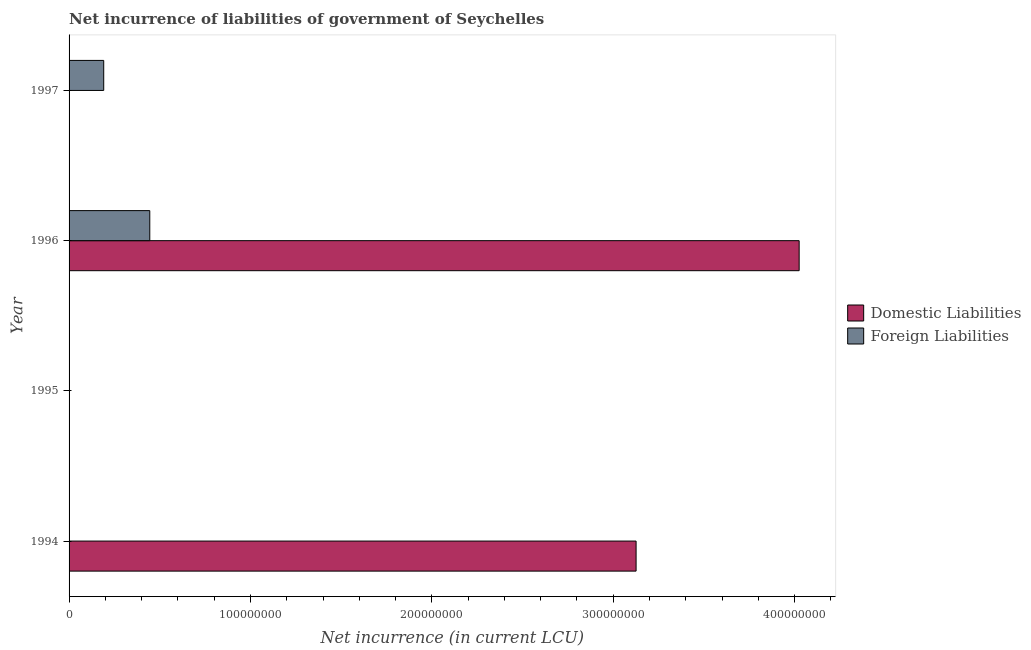How many different coloured bars are there?
Your answer should be very brief. 2. How many bars are there on the 2nd tick from the top?
Provide a short and direct response. 2. What is the label of the 3rd group of bars from the top?
Provide a succinct answer. 1995. In how many cases, is the number of bars for a given year not equal to the number of legend labels?
Give a very brief answer. 3. Across all years, what is the maximum net incurrence of foreign liabilities?
Ensure brevity in your answer.  4.45e+07. Across all years, what is the minimum net incurrence of foreign liabilities?
Provide a succinct answer. 0. What is the total net incurrence of foreign liabilities in the graph?
Give a very brief answer. 6.36e+07. What is the difference between the net incurrence of foreign liabilities in 1996 and that in 1997?
Give a very brief answer. 2.54e+07. What is the difference between the net incurrence of domestic liabilities in 1996 and the net incurrence of foreign liabilities in 1997?
Your response must be concise. 3.83e+08. What is the average net incurrence of foreign liabilities per year?
Offer a terse response. 1.59e+07. In the year 1996, what is the difference between the net incurrence of domestic liabilities and net incurrence of foreign liabilities?
Keep it short and to the point. 3.58e+08. In how many years, is the net incurrence of domestic liabilities greater than 60000000 LCU?
Offer a terse response. 2. What is the ratio of the net incurrence of foreign liabilities in 1996 to that in 1997?
Keep it short and to the point. 2.33. What is the difference between the highest and the lowest net incurrence of domestic liabilities?
Offer a terse response. 4.02e+08. How many bars are there?
Offer a terse response. 4. Are all the bars in the graph horizontal?
Give a very brief answer. Yes. Does the graph contain any zero values?
Your answer should be compact. Yes. What is the title of the graph?
Your response must be concise. Net incurrence of liabilities of government of Seychelles. Does "Rural Population" appear as one of the legend labels in the graph?
Your answer should be compact. No. What is the label or title of the X-axis?
Offer a very short reply. Net incurrence (in current LCU). What is the label or title of the Y-axis?
Provide a short and direct response. Year. What is the Net incurrence (in current LCU) in Domestic Liabilities in 1994?
Your response must be concise. 3.13e+08. What is the Net incurrence (in current LCU) in Domestic Liabilities in 1996?
Give a very brief answer. 4.02e+08. What is the Net incurrence (in current LCU) of Foreign Liabilities in 1996?
Keep it short and to the point. 4.45e+07. What is the Net incurrence (in current LCU) of Domestic Liabilities in 1997?
Make the answer very short. 0. What is the Net incurrence (in current LCU) in Foreign Liabilities in 1997?
Give a very brief answer. 1.91e+07. Across all years, what is the maximum Net incurrence (in current LCU) in Domestic Liabilities?
Keep it short and to the point. 4.02e+08. Across all years, what is the maximum Net incurrence (in current LCU) of Foreign Liabilities?
Provide a short and direct response. 4.45e+07. What is the total Net incurrence (in current LCU) of Domestic Liabilities in the graph?
Make the answer very short. 7.15e+08. What is the total Net incurrence (in current LCU) of Foreign Liabilities in the graph?
Offer a terse response. 6.36e+07. What is the difference between the Net incurrence (in current LCU) in Domestic Liabilities in 1994 and that in 1996?
Give a very brief answer. -8.99e+07. What is the difference between the Net incurrence (in current LCU) in Foreign Liabilities in 1996 and that in 1997?
Give a very brief answer. 2.54e+07. What is the difference between the Net incurrence (in current LCU) in Domestic Liabilities in 1994 and the Net incurrence (in current LCU) in Foreign Liabilities in 1996?
Ensure brevity in your answer.  2.68e+08. What is the difference between the Net incurrence (in current LCU) in Domestic Liabilities in 1994 and the Net incurrence (in current LCU) in Foreign Liabilities in 1997?
Your answer should be compact. 2.94e+08. What is the difference between the Net incurrence (in current LCU) in Domestic Liabilities in 1996 and the Net incurrence (in current LCU) in Foreign Liabilities in 1997?
Your answer should be compact. 3.83e+08. What is the average Net incurrence (in current LCU) of Domestic Liabilities per year?
Make the answer very short. 1.79e+08. What is the average Net incurrence (in current LCU) of Foreign Liabilities per year?
Make the answer very short. 1.59e+07. In the year 1996, what is the difference between the Net incurrence (in current LCU) in Domestic Liabilities and Net incurrence (in current LCU) in Foreign Liabilities?
Provide a succinct answer. 3.58e+08. What is the ratio of the Net incurrence (in current LCU) in Domestic Liabilities in 1994 to that in 1996?
Ensure brevity in your answer.  0.78. What is the ratio of the Net incurrence (in current LCU) in Foreign Liabilities in 1996 to that in 1997?
Offer a terse response. 2.33. What is the difference between the highest and the lowest Net incurrence (in current LCU) of Domestic Liabilities?
Offer a very short reply. 4.02e+08. What is the difference between the highest and the lowest Net incurrence (in current LCU) in Foreign Liabilities?
Ensure brevity in your answer.  4.45e+07. 